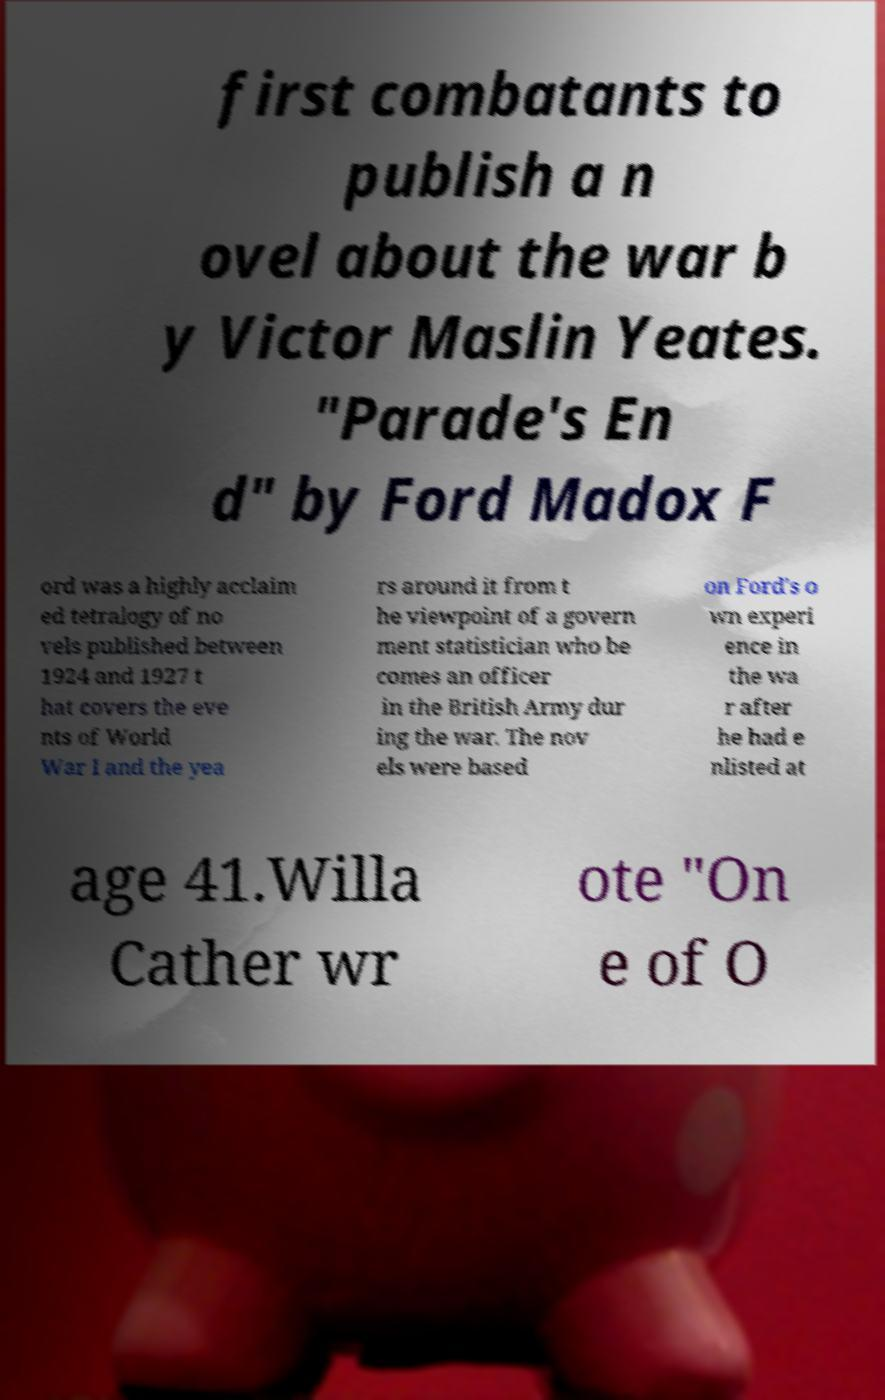There's text embedded in this image that I need extracted. Can you transcribe it verbatim? first combatants to publish a n ovel about the war b y Victor Maslin Yeates. "Parade's En d" by Ford Madox F ord was a highly acclaim ed tetralogy of no vels published between 1924 and 1927 t hat covers the eve nts of World War I and the yea rs around it from t he viewpoint of a govern ment statistician who be comes an officer in the British Army dur ing the war. The nov els were based on Ford's o wn experi ence in the wa r after he had e nlisted at age 41.Willa Cather wr ote "On e of O 